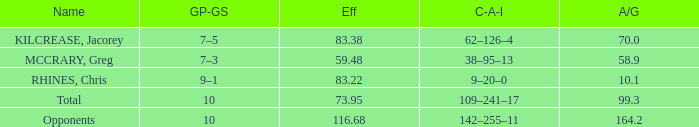Help me parse the entirety of this table. {'header': ['Name', 'GP-GS', 'Eff', 'C-A-I', 'A/G'], 'rows': [['KILCREASE, Jacorey', '7–5', '83.38', '62–126–4', '70.0'], ['MCCRARY, Greg', '7–3', '59.48', '38–95–13', '58.9'], ['RHINES, Chris', '9–1', '83.22', '9–20–0', '10.1'], ['Total', '10', '73.95', '109–241–17', '99.3'], ['Opponents', '10', '116.68', '142–255–11', '164.2']]} What is the total avg/g of McCrary, Greg? 1.0. 